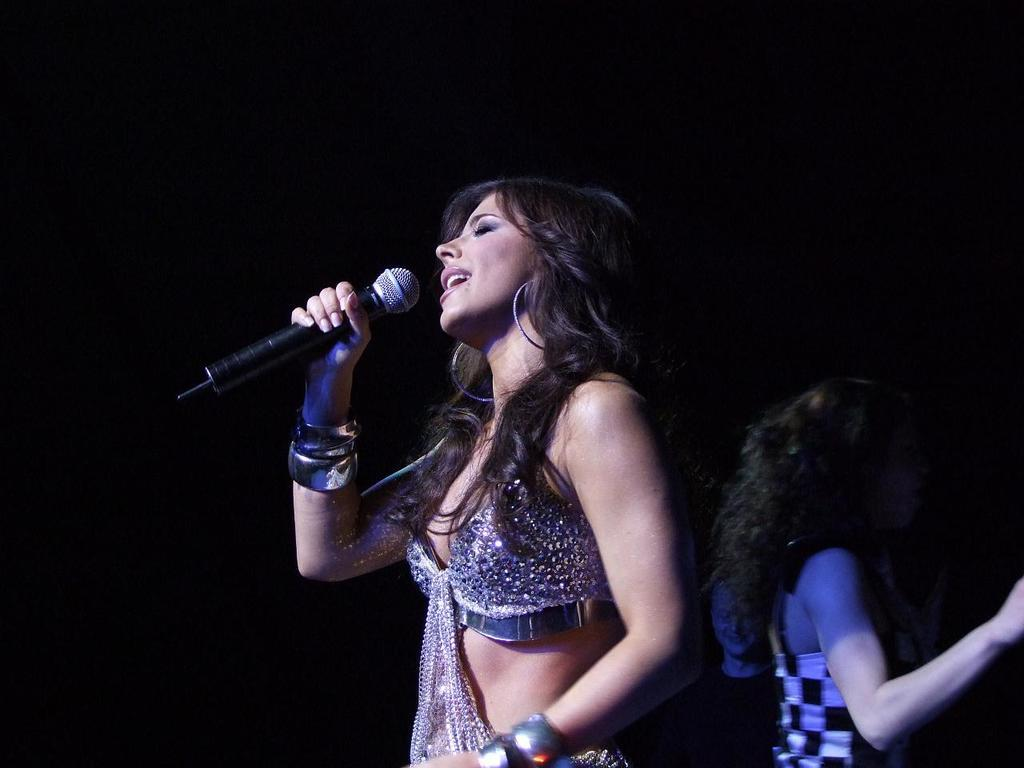Who is the main subject in the image? There is a woman in the center of the image. What is the woman in the center doing? The woman is standing and singing. What is the woman holding in the image? The woman is holding a microphone. Can you describe the other woman in the image? There is another woman to the right of the center. What is the color of the background in the image? The background of the image is dark. What type of toothbrush is the woman using while singing in the image? There is no toothbrush present in the image; the woman is holding a microphone and singing. Is there a birthday celebration happening in the image? There is no indication of a birthday celebration in the image. 